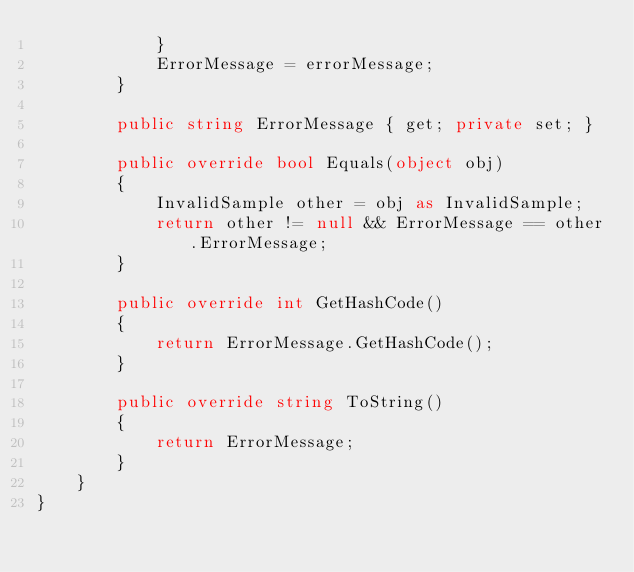Convert code to text. <code><loc_0><loc_0><loc_500><loc_500><_C#_>            }
            ErrorMessage = errorMessage;
        }

        public string ErrorMessage { get; private set; }

        public override bool Equals(object obj)
        {
            InvalidSample other = obj as InvalidSample;
            return other != null && ErrorMessage == other.ErrorMessage;
        }

        public override int GetHashCode()
        {
            return ErrorMessage.GetHashCode();
        }

        public override string ToString()
        {
            return ErrorMessage;
        }
    }
}</code> 